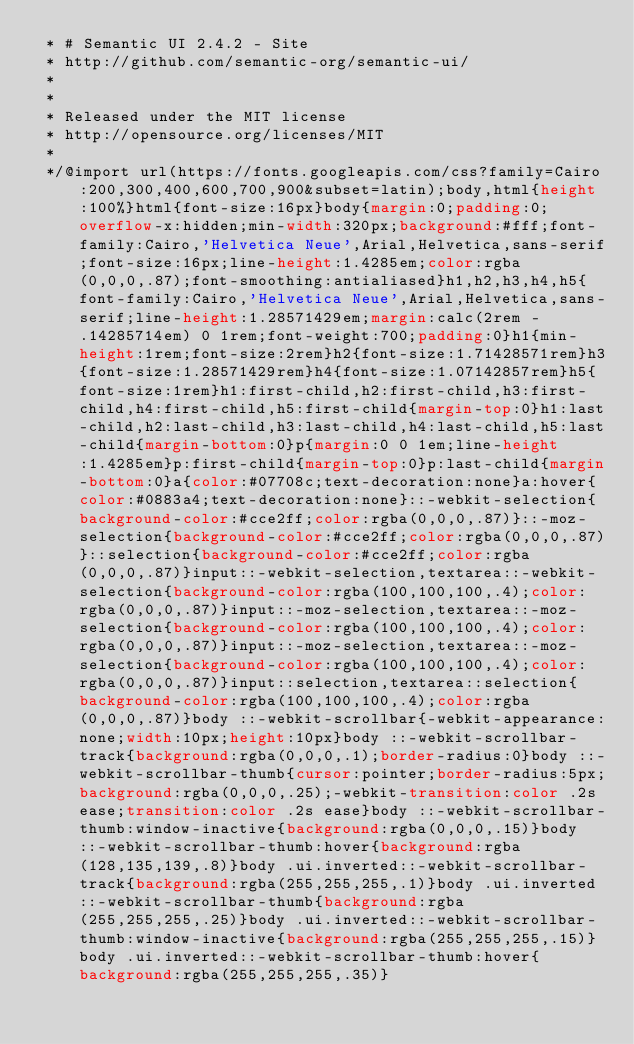Convert code to text. <code><loc_0><loc_0><loc_500><loc_500><_CSS_> * # Semantic UI 2.4.2 - Site
 * http://github.com/semantic-org/semantic-ui/
 *
 *
 * Released under the MIT license
 * http://opensource.org/licenses/MIT
 *
 */@import url(https://fonts.googleapis.com/css?family=Cairo:200,300,400,600,700,900&subset=latin);body,html{height:100%}html{font-size:16px}body{margin:0;padding:0;overflow-x:hidden;min-width:320px;background:#fff;font-family:Cairo,'Helvetica Neue',Arial,Helvetica,sans-serif;font-size:16px;line-height:1.4285em;color:rgba(0,0,0,.87);font-smoothing:antialiased}h1,h2,h3,h4,h5{font-family:Cairo,'Helvetica Neue',Arial,Helvetica,sans-serif;line-height:1.28571429em;margin:calc(2rem - .14285714em) 0 1rem;font-weight:700;padding:0}h1{min-height:1rem;font-size:2rem}h2{font-size:1.71428571rem}h3{font-size:1.28571429rem}h4{font-size:1.07142857rem}h5{font-size:1rem}h1:first-child,h2:first-child,h3:first-child,h4:first-child,h5:first-child{margin-top:0}h1:last-child,h2:last-child,h3:last-child,h4:last-child,h5:last-child{margin-bottom:0}p{margin:0 0 1em;line-height:1.4285em}p:first-child{margin-top:0}p:last-child{margin-bottom:0}a{color:#07708c;text-decoration:none}a:hover{color:#0883a4;text-decoration:none}::-webkit-selection{background-color:#cce2ff;color:rgba(0,0,0,.87)}::-moz-selection{background-color:#cce2ff;color:rgba(0,0,0,.87)}::selection{background-color:#cce2ff;color:rgba(0,0,0,.87)}input::-webkit-selection,textarea::-webkit-selection{background-color:rgba(100,100,100,.4);color:rgba(0,0,0,.87)}input::-moz-selection,textarea::-moz-selection{background-color:rgba(100,100,100,.4);color:rgba(0,0,0,.87)}input::-moz-selection,textarea::-moz-selection{background-color:rgba(100,100,100,.4);color:rgba(0,0,0,.87)}input::selection,textarea::selection{background-color:rgba(100,100,100,.4);color:rgba(0,0,0,.87)}body ::-webkit-scrollbar{-webkit-appearance:none;width:10px;height:10px}body ::-webkit-scrollbar-track{background:rgba(0,0,0,.1);border-radius:0}body ::-webkit-scrollbar-thumb{cursor:pointer;border-radius:5px;background:rgba(0,0,0,.25);-webkit-transition:color .2s ease;transition:color .2s ease}body ::-webkit-scrollbar-thumb:window-inactive{background:rgba(0,0,0,.15)}body ::-webkit-scrollbar-thumb:hover{background:rgba(128,135,139,.8)}body .ui.inverted::-webkit-scrollbar-track{background:rgba(255,255,255,.1)}body .ui.inverted::-webkit-scrollbar-thumb{background:rgba(255,255,255,.25)}body .ui.inverted::-webkit-scrollbar-thumb:window-inactive{background:rgba(255,255,255,.15)}body .ui.inverted::-webkit-scrollbar-thumb:hover{background:rgba(255,255,255,.35)}</code> 